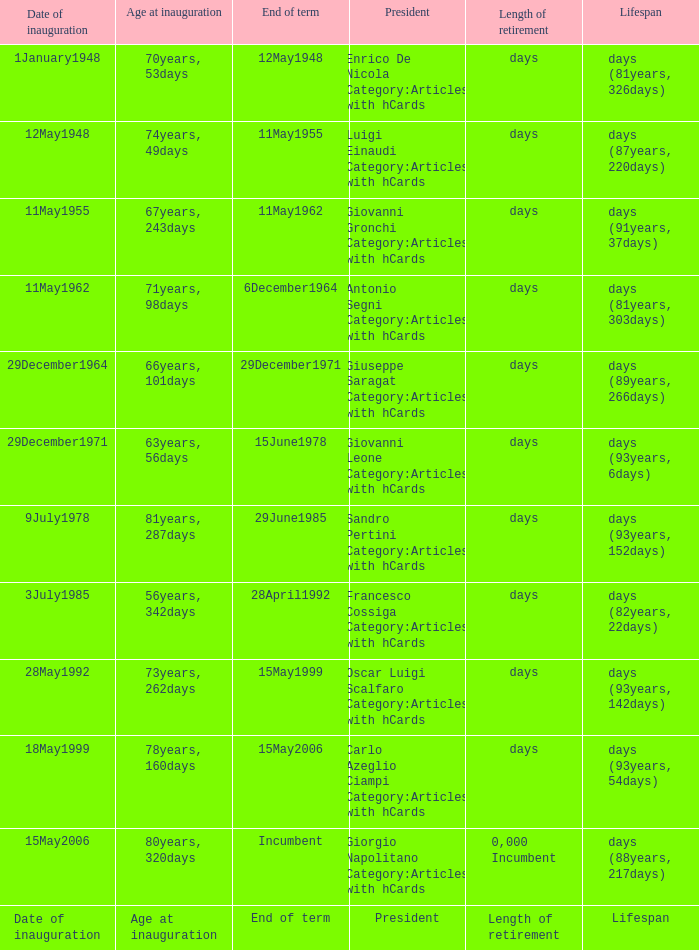What is the End of term of the President with an Age at inauguration of 78years, 160days? 15May2006. 